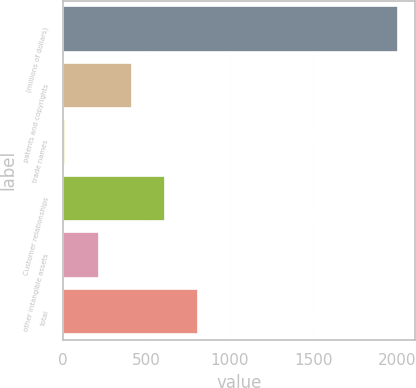<chart> <loc_0><loc_0><loc_500><loc_500><bar_chart><fcel>(millions of dollars)<fcel>patents and copyrights<fcel>trade names<fcel>Customer relationships<fcel>other intangible assets<fcel>total<nl><fcel>2006<fcel>413.6<fcel>15.5<fcel>612.65<fcel>214.55<fcel>811.7<nl></chart> 